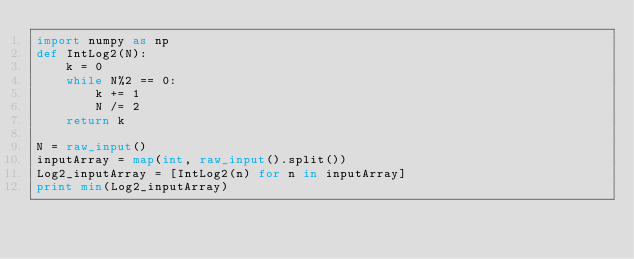Convert code to text. <code><loc_0><loc_0><loc_500><loc_500><_Python_>import numpy as np
def IntLog2(N):
    k = 0
    while N%2 == 0:
        k += 1
        N /= 2
    return k

N = raw_input()
inputArray = map(int, raw_input().split())
Log2_inputArray = [IntLog2(n) for n in inputArray]
print min(Log2_inputArray)</code> 